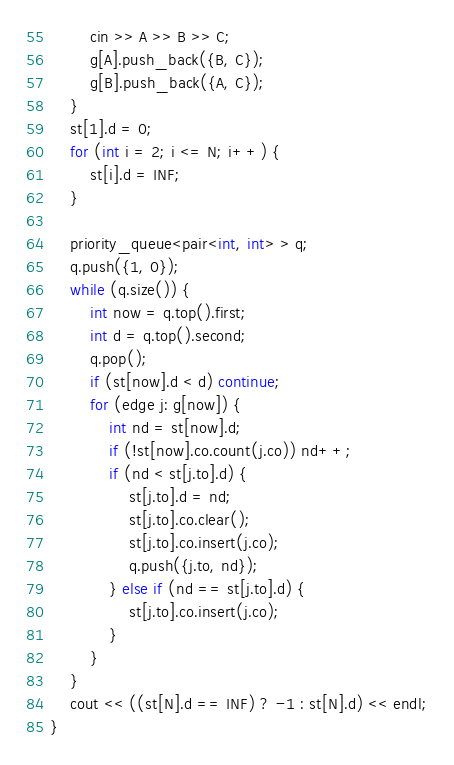Convert code to text. <code><loc_0><loc_0><loc_500><loc_500><_C++_>		cin >> A >> B >> C;
		g[A].push_back({B, C});
		g[B].push_back({A, C});
	}
	st[1].d = 0;
	for (int i = 2; i <= N; i++) {
		st[i].d = INF;
	}

	priority_queue<pair<int, int> > q;
	q.push({1, 0});
	while (q.size()) {
		int now = q.top().first;
		int d = q.top().second;
		q.pop();
		if (st[now].d < d) continue;
		for (edge j: g[now]) {
			int nd = st[now].d;
			if (!st[now].co.count(j.co)) nd++;
			if (nd < st[j.to].d) {
				st[j.to].d = nd;
				st[j.to].co.clear();
				st[j.to].co.insert(j.co);
				q.push({j.to, nd});
			} else if (nd == st[j.to].d) {
				st[j.to].co.insert(j.co);
			}
		}
	}
	cout << ((st[N].d == INF) ? -1 : st[N].d) << endl;
}</code> 